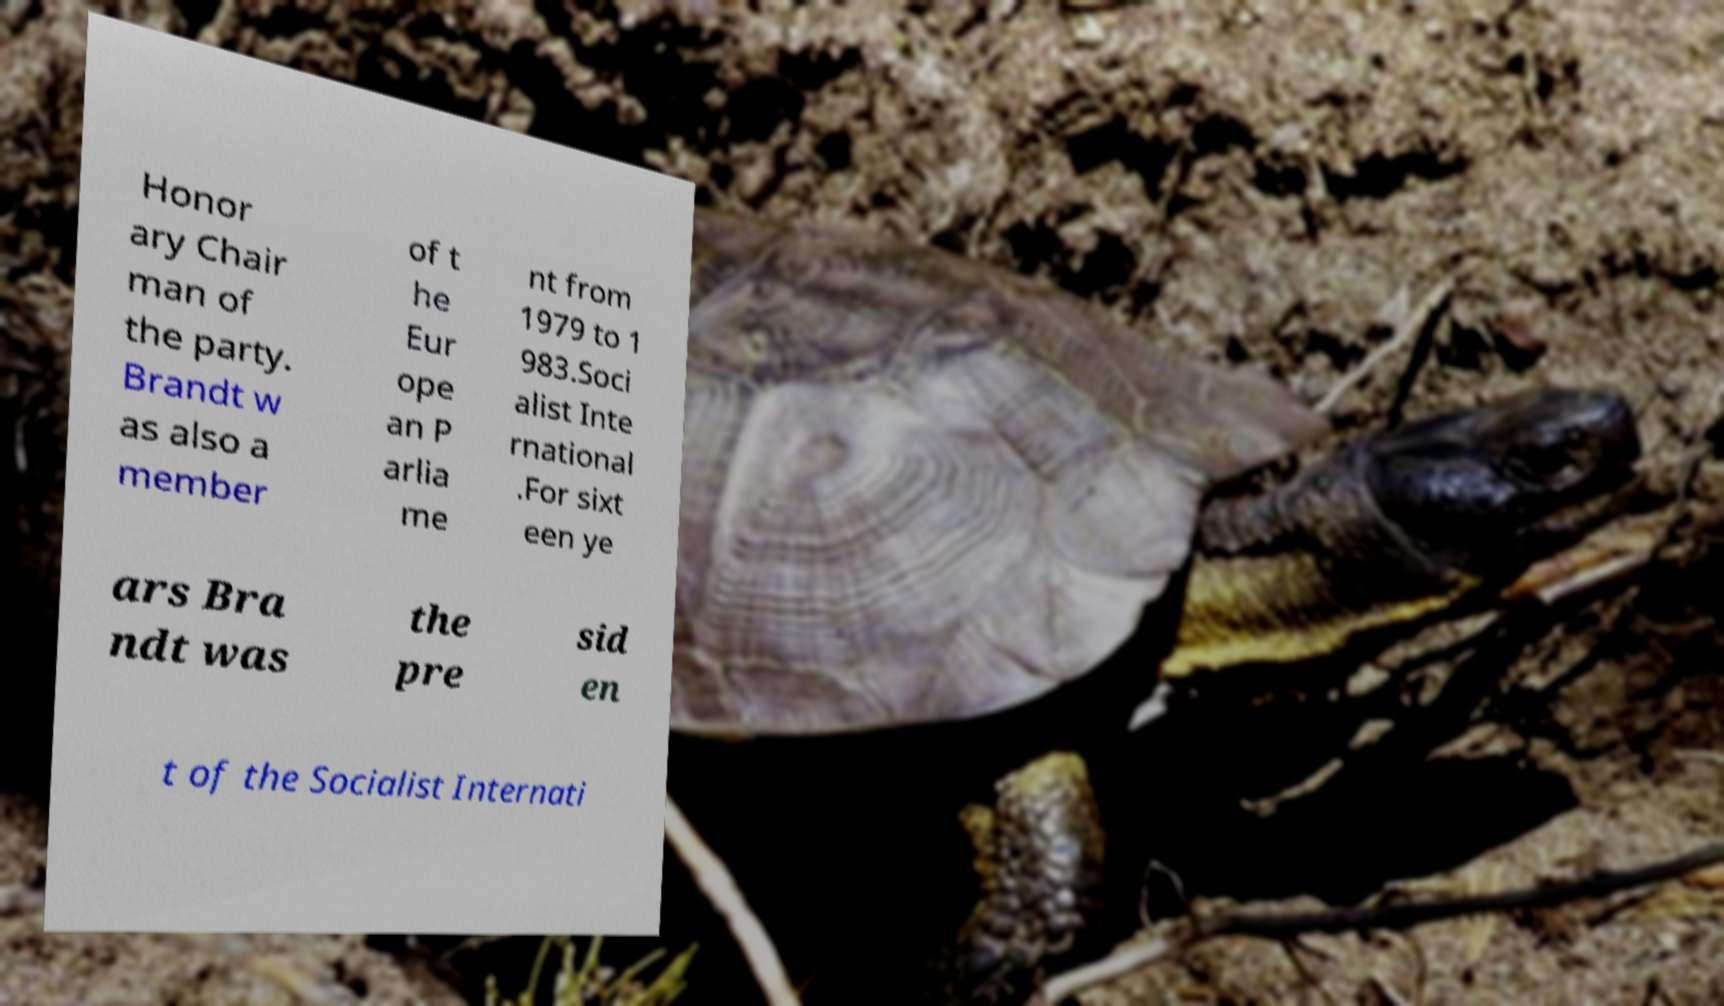Could you assist in decoding the text presented in this image and type it out clearly? Honor ary Chair man of the party. Brandt w as also a member of t he Eur ope an P arlia me nt from 1979 to 1 983.Soci alist Inte rnational .For sixt een ye ars Bra ndt was the pre sid en t of the Socialist Internati 